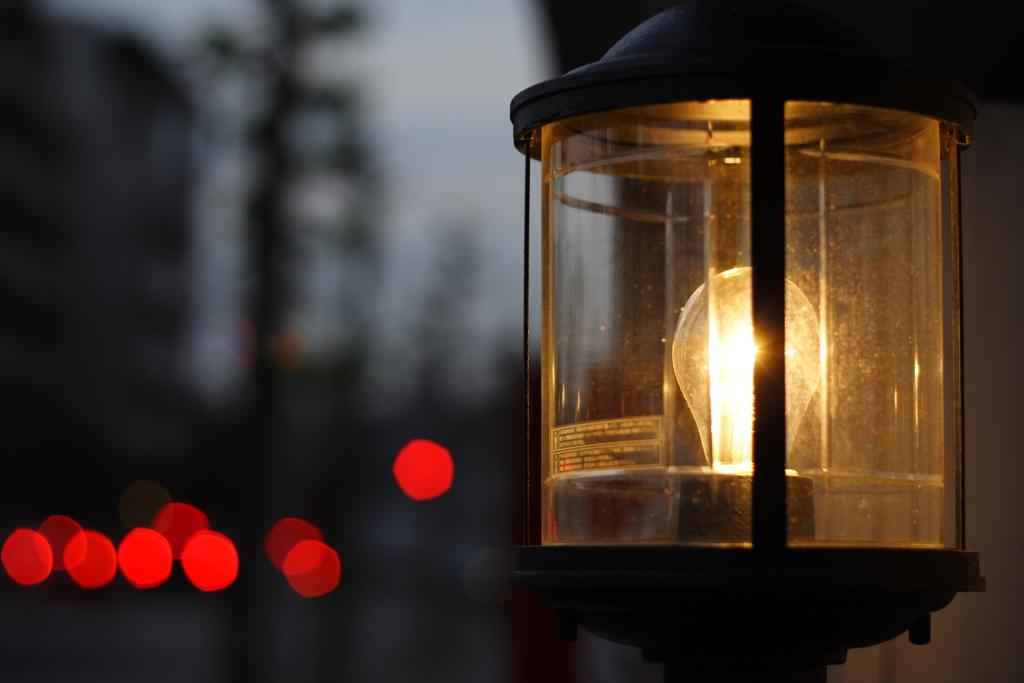What is the color of the background in the image? The background of the image is dark. What type of light sources can be seen in the image? A lantern and a bulb are present in the image. What additional visual elements are present in the image? There are red circular sparks in the image. How does the church increase its capacity in the image? There is no church present in the image, so it is not possible to determine how its capacity might be increased. 